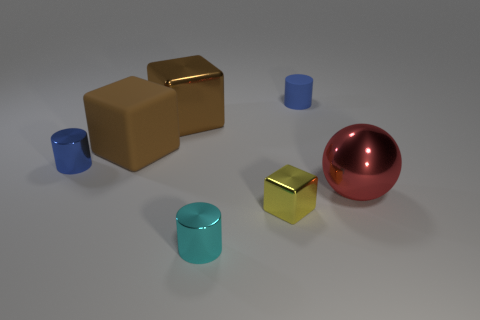Subtract all small shiny cylinders. How many cylinders are left? 1 Add 1 small cubes. How many objects exist? 8 Subtract all yellow blocks. How many blocks are left? 2 Subtract 1 cylinders. How many cylinders are left? 2 Subtract all cylinders. How many objects are left? 4 Subtract all purple balls. How many brown blocks are left? 2 Add 3 large cubes. How many large cubes exist? 5 Subtract 1 cyan cylinders. How many objects are left? 6 Subtract all yellow cylinders. Subtract all blue cubes. How many cylinders are left? 3 Subtract all yellow metal things. Subtract all brown metallic things. How many objects are left? 5 